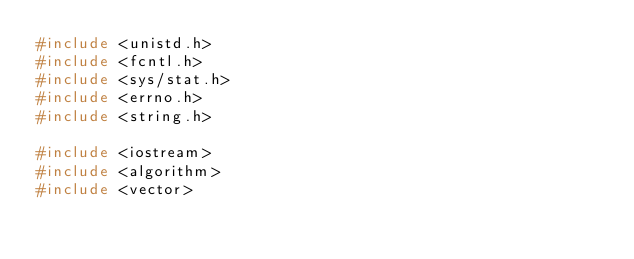Convert code to text. <code><loc_0><loc_0><loc_500><loc_500><_C++_>#include <unistd.h>
#include <fcntl.h>
#include <sys/stat.h>
#include <errno.h>
#include <string.h>

#include <iostream>
#include <algorithm>
#include <vector>
</code> 